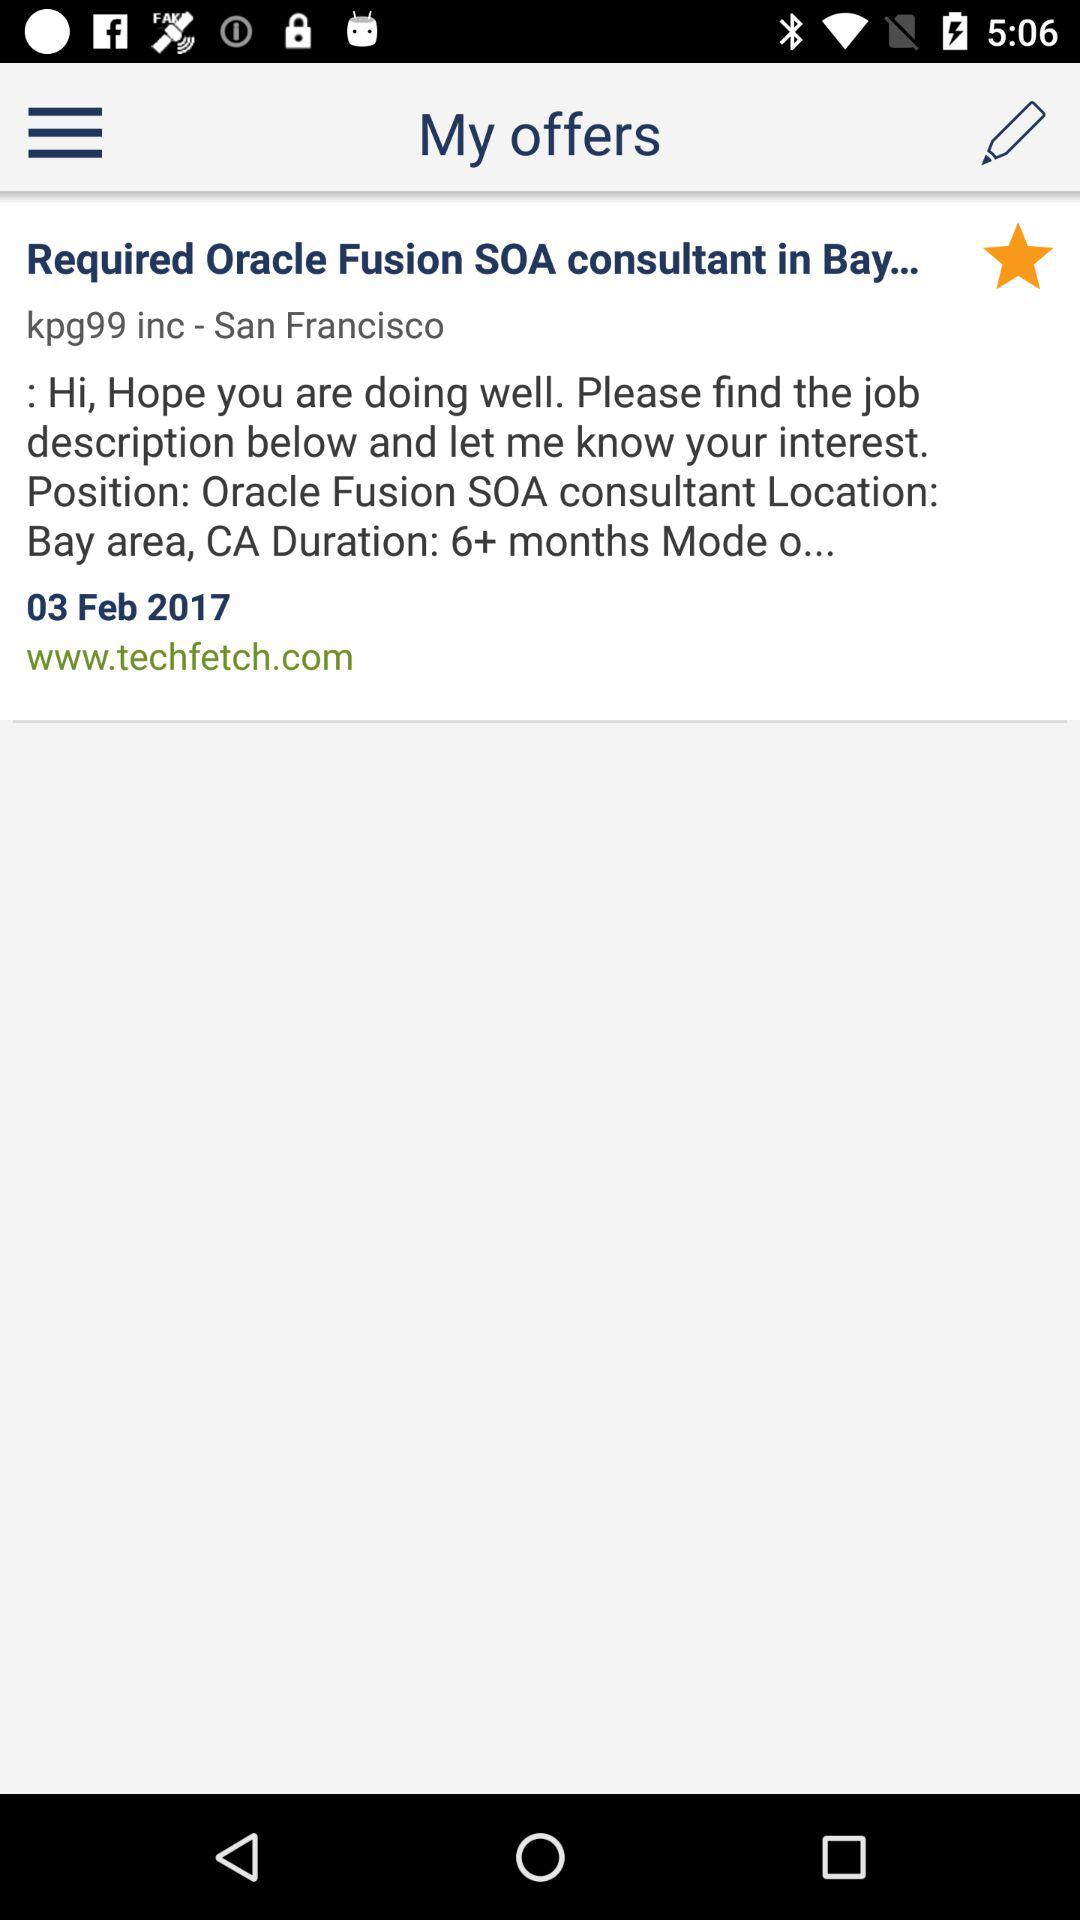What's the website address? The website address is www.techfetch.com. 